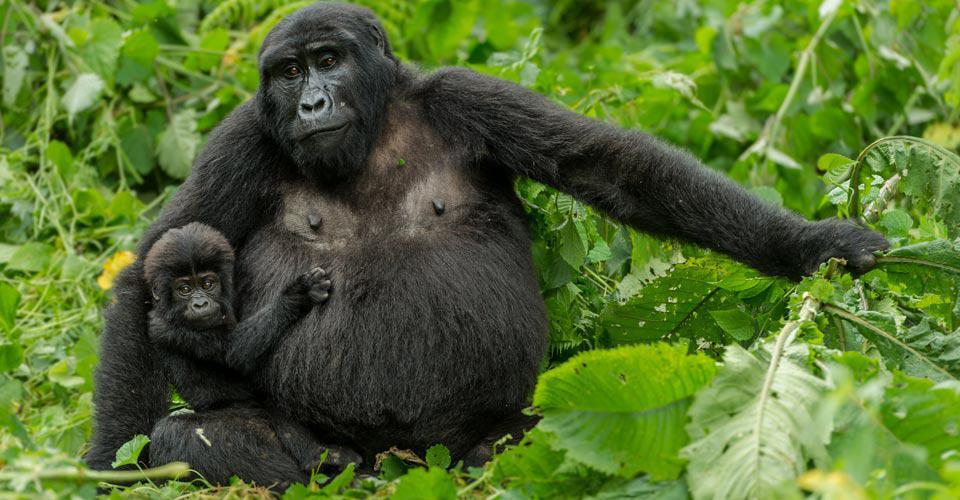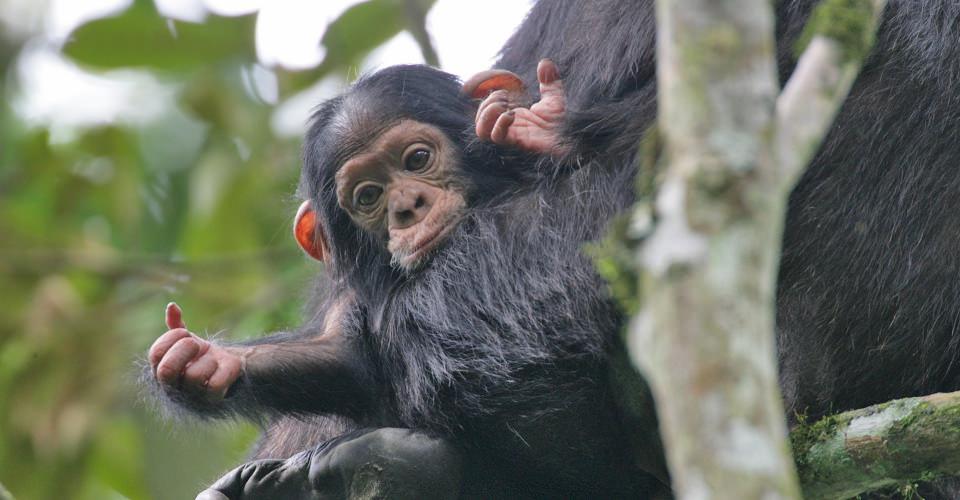The first image is the image on the left, the second image is the image on the right. Examine the images to the left and right. Is the description "The left image contains exactly one silver back gorilla." accurate? Answer yes or no. No. The first image is the image on the left, the second image is the image on the right. Evaluate the accuracy of this statement regarding the images: "The left image shows a single silverback male gorilla, and the right image shows a group of gorillas of various ages and sizes.". Is it true? Answer yes or no. No. 